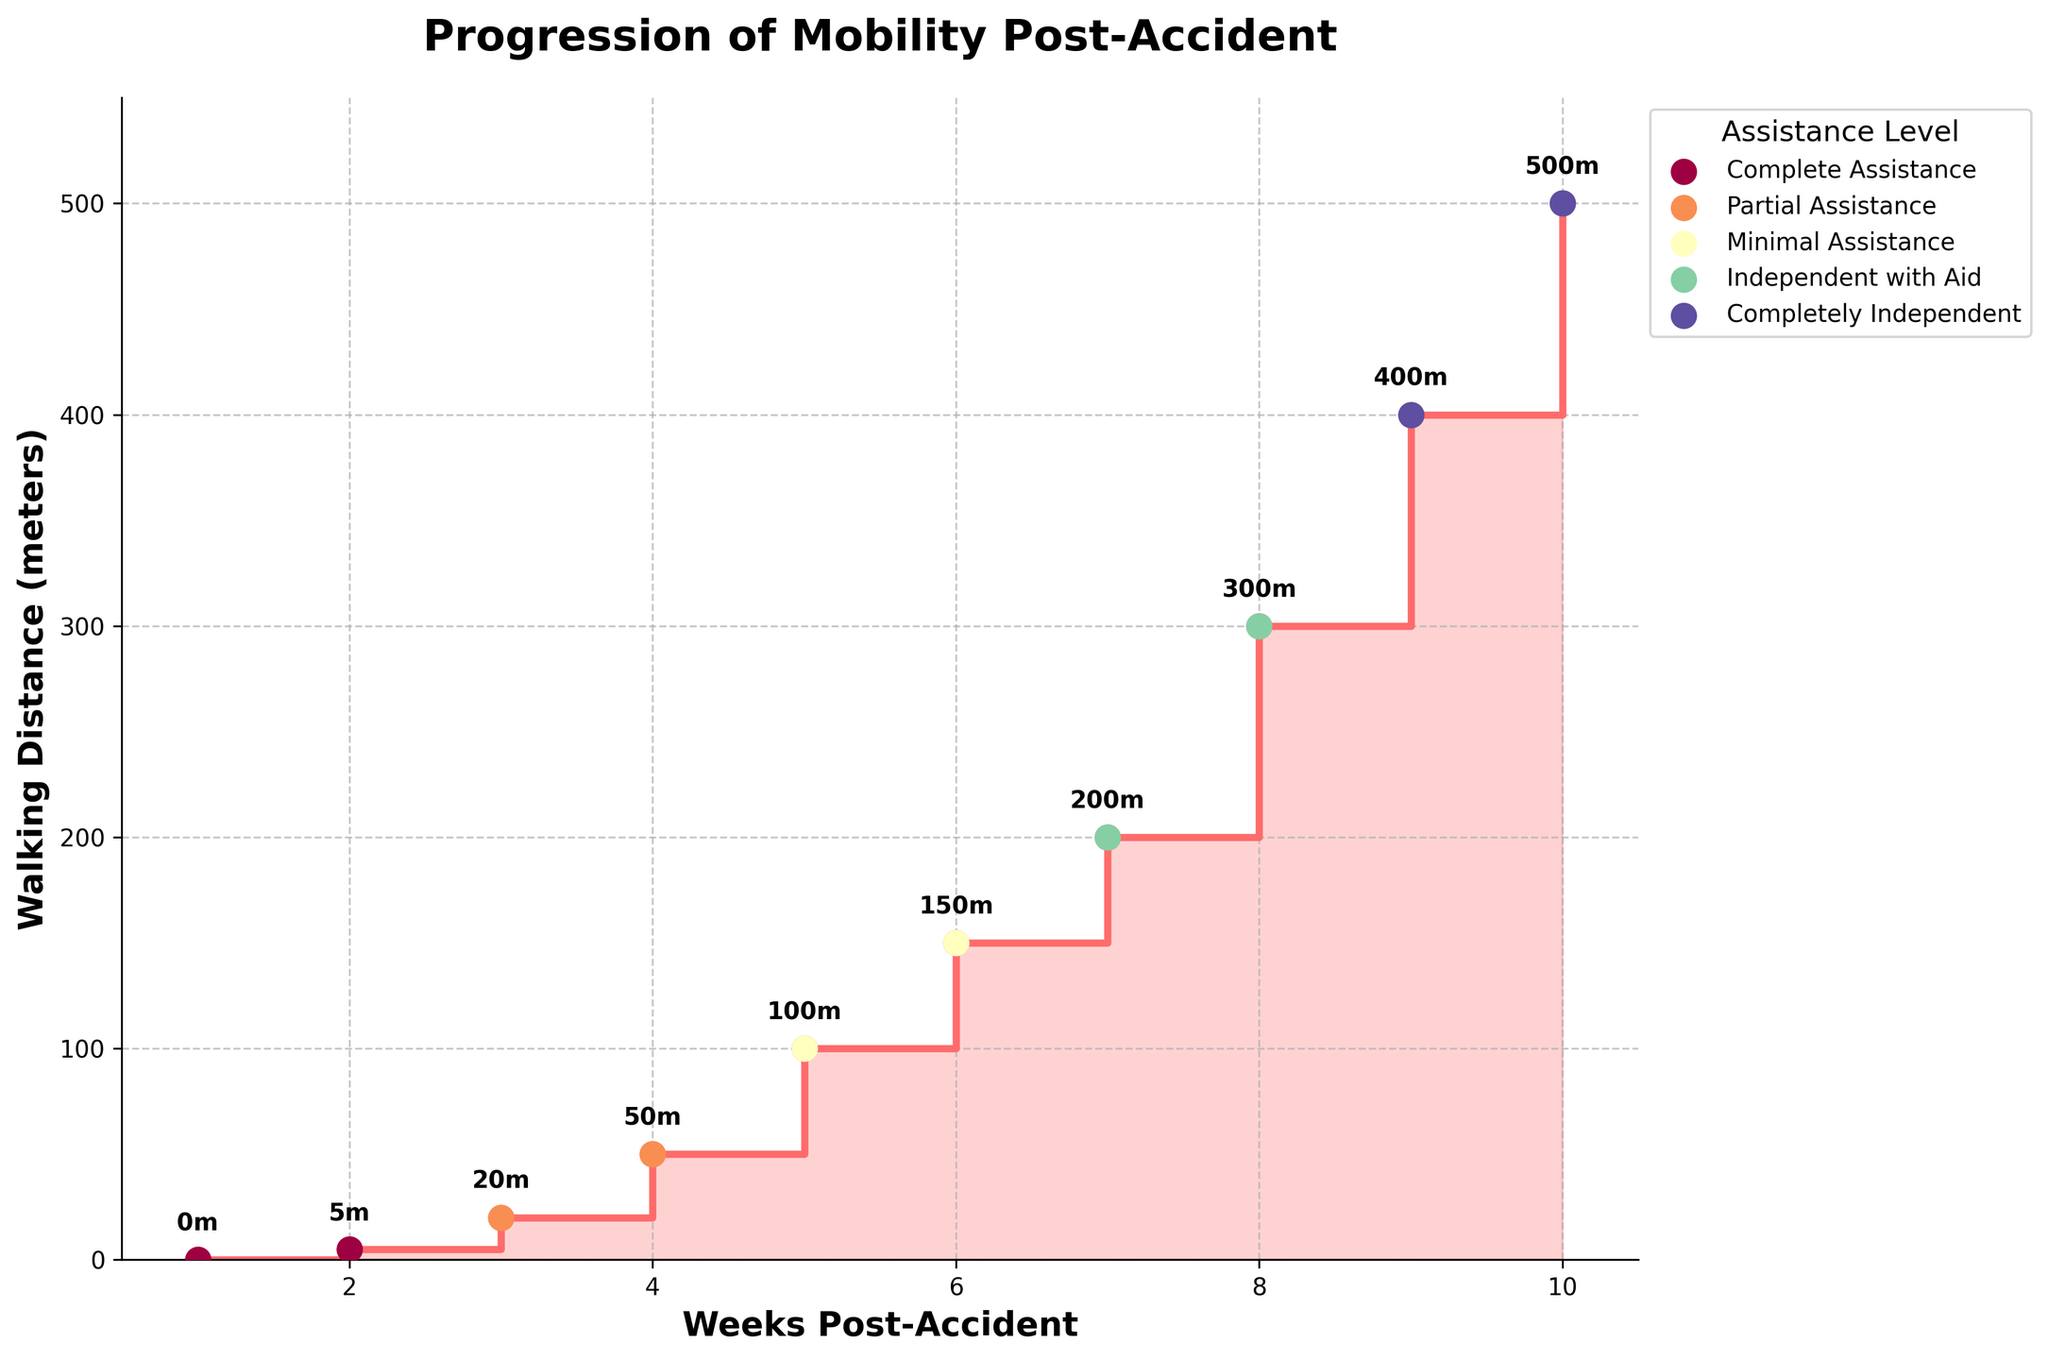What is the title of the figure? The title of the figure is displayed at the top and is bold and larger than other text elements.
Answer: Progression of Mobility Post-Accident How many weeks of data are shown in the figure? The x-axis, labeled 'Weeks Post-Accident', ranges from 1 to 10, indicating 10 weeks of data.
Answer: 10 What is the walking distance at 5 weeks post-accident? Locate week 5 on the x-axis and find the corresponding value on the y-axis. The annotation near the marker shows '100m'.
Answer: 100 meters Which week showed the largest improvement in walking distance? Compare the step heights between consecutive weeks on the stair plot. The largest step is between week 8 (300m) and week 9 (400m).
Answer: Week 9 How did the assistance level change over the weeks? Inspect the colors and labels of the markers and their progression over the weeks. Week 1 starts with 'Complete Assistance', and it changes progressively to 'Completely Independent' by week 9.
Answer: Changed from Complete Assistance to Completely Independent What is the average walking distance from week 6 to week 10? Sum the walking distances from week 6 (150m), week 7 (200m), week 8 (300m), week 9 (400m), and week 10 (500m) and divide by 5. (150 + 200 + 300 + 400 + 500) / 5 = 1550 / 5 = 310
Answer: 310 meters Which week had the highest number of physiotherapy sessions? Check the data for physiotherapy sessions and find the highest value, which is 7 in week 4.
Answer: Week 4 How does the pain level change over the weeks? The pain level is annotated and decreases progressively from week 1 (8) to week 10 (0).
Answer: Decreased from 8 to 0 Compare the walking distance in week 3 and week 7; which week shows greater mobility? Find and compare the walking distances at weeks 3 (20m) and 7 (200m). Week 7 has greater mobility.
Answer: Week 7 What is the total increase in walking distance from week 1 to week 10? Subtract the walking distance at week 1 (0m) from the walking distance at week 10 (500m): 500 - 0 = 500.
Answer: 500 meters 